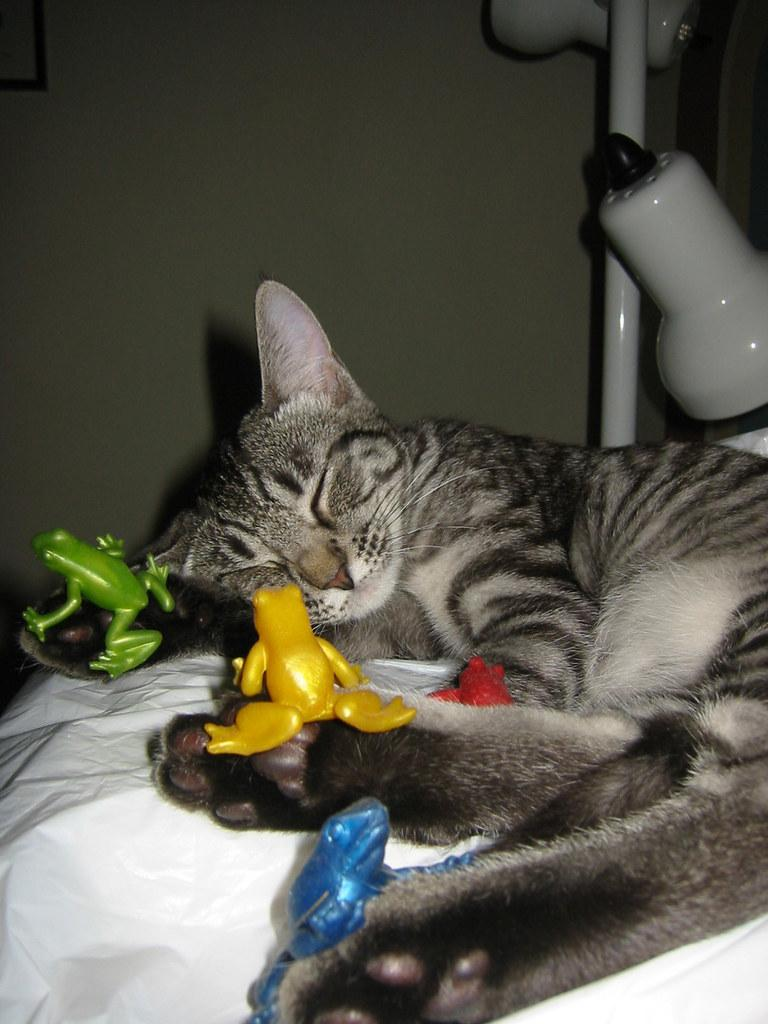What type of animal is present in the image? There is a cat in the image. What else can be seen in the image besides the cat? There are toys visible in the image. What can be seen in the background of the image? There is a wall visible in the background of the image. What type of dress is the cat wearing in the image? There is no dress present in the image, as cats do not wear clothing. 